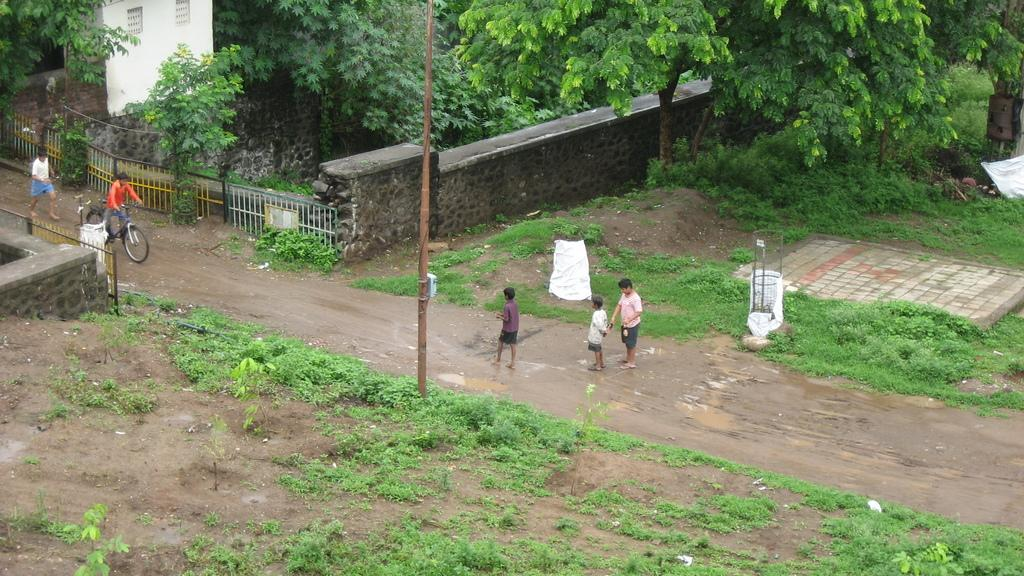What are the people in the image doing? The people in the image are on the road. Can you describe the mode of transportation of one person in the image? One person is riding a bicycle. What type of natural elements can be seen in the image? There are trees, plants, and grass in the image. What man-made structures are present in the image? There are fences and a wall in the image. What type of stamp is being used by the person riding the bicycle in the image? There is no stamp present in the image; the person is riding a bicycle. How does the digestion of the plants in the image contribute to the overall ecosystem? The image does not provide information about the digestion of the plants or their contribution to the ecosystem. 